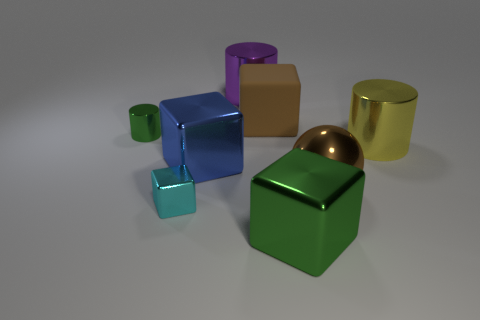Subtract 1 cubes. How many cubes are left? 3 Add 1 yellow metallic objects. How many objects exist? 9 Subtract all yellow blocks. Subtract all yellow cylinders. How many blocks are left? 4 Subtract all spheres. How many objects are left? 7 Add 3 big metallic spheres. How many big metallic spheres are left? 4 Add 3 large green rubber objects. How many large green rubber objects exist? 3 Subtract 0 red cylinders. How many objects are left? 8 Subtract all tiny yellow rubber blocks. Subtract all big brown shiny objects. How many objects are left? 7 